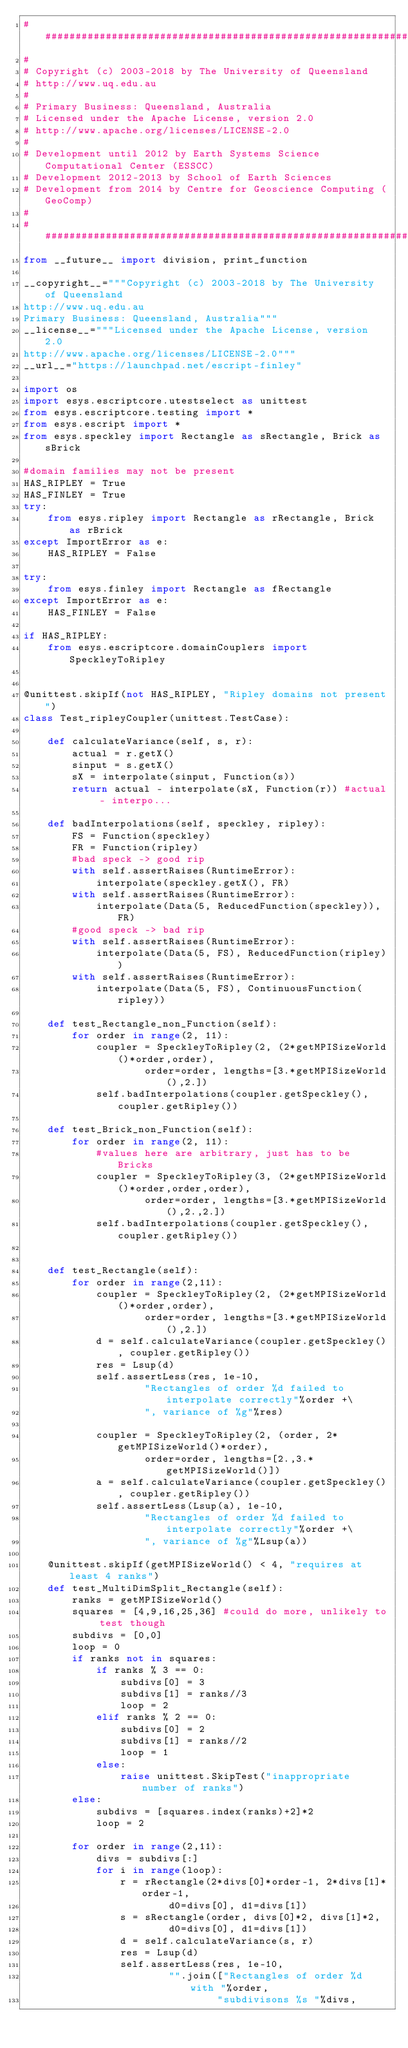Convert code to text. <code><loc_0><loc_0><loc_500><loc_500><_Python_>##############################################################################
#
# Copyright (c) 2003-2018 by The University of Queensland
# http://www.uq.edu.au
#
# Primary Business: Queensland, Australia
# Licensed under the Apache License, version 2.0
# http://www.apache.org/licenses/LICENSE-2.0
#
# Development until 2012 by Earth Systems Science Computational Center (ESSCC)
# Development 2012-2013 by School of Earth Sciences
# Development from 2014 by Centre for Geoscience Computing (GeoComp)
#
##############################################################################
from __future__ import division, print_function

__copyright__="""Copyright (c) 2003-2018 by The University of Queensland
http://www.uq.edu.au
Primary Business: Queensland, Australia"""
__license__="""Licensed under the Apache License, version 2.0
http://www.apache.org/licenses/LICENSE-2.0"""
__url__="https://launchpad.net/escript-finley"

import os
import esys.escriptcore.utestselect as unittest
from esys.escriptcore.testing import *
from esys.escript import *
from esys.speckley import Rectangle as sRectangle, Brick as sBrick

#domain families may not be present
HAS_RIPLEY = True
HAS_FINLEY = True
try:
    from esys.ripley import Rectangle as rRectangle, Brick as rBrick
except ImportError as e:
    HAS_RIPLEY = False
    
try:
    from esys.finley import Rectangle as fRectangle
except ImportError as e:
    HAS_FINLEY = False

if HAS_RIPLEY:
    from esys.escriptcore.domainCouplers import SpeckleyToRipley


@unittest.skipIf(not HAS_RIPLEY, "Ripley domains not present")
class Test_ripleyCoupler(unittest.TestCase):

    def calculateVariance(self, s, r):
        actual = r.getX()
        sinput = s.getX()
        sX = interpolate(sinput, Function(s))
        return actual - interpolate(sX, Function(r)) #actual - interpo...

    def badInterpolations(self, speckley, ripley):
        FS = Function(speckley)
        FR = Function(ripley)
        #bad speck -> good rip
        with self.assertRaises(RuntimeError):
            interpolate(speckley.getX(), FR)
        with self.assertRaises(RuntimeError):
            interpolate(Data(5, ReducedFunction(speckley)), FR)
        #good speck -> bad rip
        with self.assertRaises(RuntimeError):
            interpolate(Data(5, FS), ReducedFunction(ripley))
        with self.assertRaises(RuntimeError):
            interpolate(Data(5, FS), ContinuousFunction(ripley))

    def test_Rectangle_non_Function(self):
        for order in range(2, 11):
            coupler = SpeckleyToRipley(2, (2*getMPISizeWorld()*order,order),
                    order=order, lengths=[3.*getMPISizeWorld(),2.])
            self.badInterpolations(coupler.getSpeckley(), coupler.getRipley())

    def test_Brick_non_Function(self):
        for order in range(2, 11):
            #values here are arbitrary, just has to be Bricks
            coupler = SpeckleyToRipley(3, (2*getMPISizeWorld()*order,order,order),
                    order=order, lengths=[3.*getMPISizeWorld(),2.,2.])
            self.badInterpolations(coupler.getSpeckley(), coupler.getRipley())


    def test_Rectangle(self):
        for order in range(2,11):
            coupler = SpeckleyToRipley(2, (2*getMPISizeWorld()*order,order),
                    order=order, lengths=[3.*getMPISizeWorld(),2.])
            d = self.calculateVariance(coupler.getSpeckley(), coupler.getRipley())
            res = Lsup(d)
            self.assertLess(res, 1e-10,
                    "Rectangles of order %d failed to interpolate correctly"%order +\
                    ", variance of %g"%res)

            coupler = SpeckleyToRipley(2, (order, 2*getMPISizeWorld()*order),
                    order=order, lengths=[2.,3.*getMPISizeWorld()])
            a = self.calculateVariance(coupler.getSpeckley(), coupler.getRipley())
            self.assertLess(Lsup(a), 1e-10,
                    "Rectangles of order %d failed to interpolate correctly"%order +\
                    ", variance of %g"%Lsup(a))

    @unittest.skipIf(getMPISizeWorld() < 4, "requires at least 4 ranks")
    def test_MultiDimSplit_Rectangle(self):
        ranks = getMPISizeWorld()
        squares = [4,9,16,25,36] #could do more, unlikely to test though
        subdivs = [0,0]
        loop = 0
        if ranks not in squares:
            if ranks % 3 == 0:
                subdivs[0] = 3
                subdivs[1] = ranks//3
                loop = 2
            elif ranks % 2 == 0:
                subdivs[0] = 2
                subdivs[1] = ranks//2
                loop = 1
            else:
                raise unittest.SkipTest("inappropriate number of ranks")
        else:
            subdivs = [squares.index(ranks)+2]*2
            loop = 2

        for order in range(2,11):
            divs = subdivs[:]
            for i in range(loop):
                r = rRectangle(2*divs[0]*order-1, 2*divs[1]*order-1,
                        d0=divs[0], d1=divs[1])
                s = sRectangle(order, divs[0]*2, divs[1]*2,
                        d0=divs[0], d1=divs[1])
                d = self.calculateVariance(s, r)
                res = Lsup(d)
                self.assertLess(res, 1e-10,
                        "".join(["Rectangles of order %d with "%order,
                                "subdivisons %s "%divs,</code> 